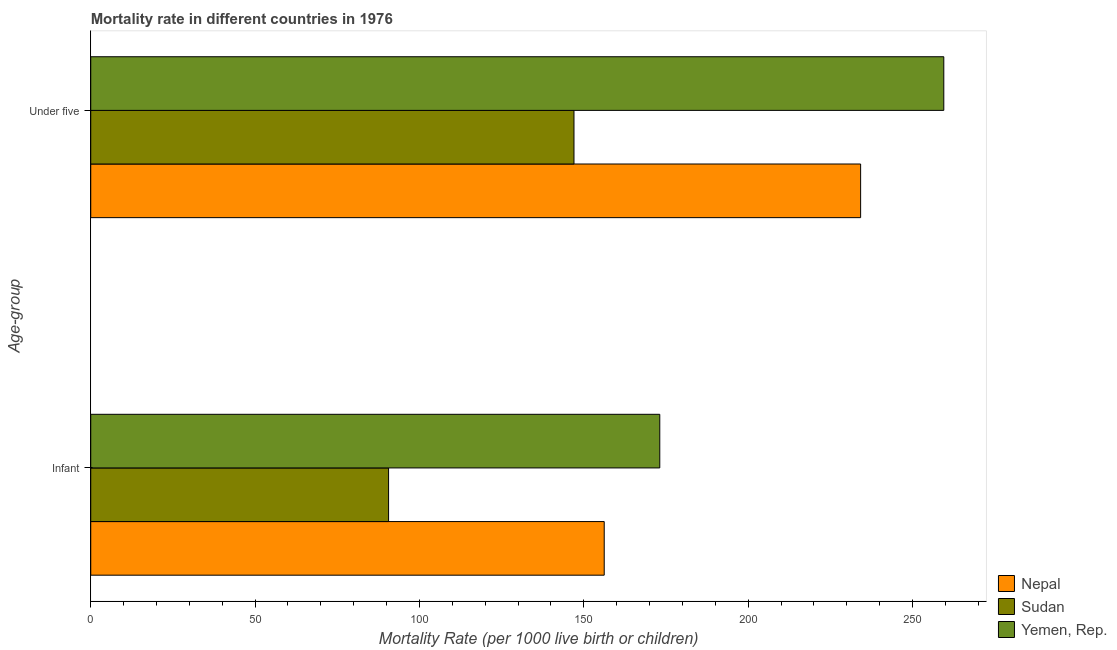How many different coloured bars are there?
Make the answer very short. 3. How many groups of bars are there?
Offer a terse response. 2. Are the number of bars on each tick of the Y-axis equal?
Your answer should be very brief. Yes. How many bars are there on the 1st tick from the bottom?
Your answer should be very brief. 3. What is the label of the 1st group of bars from the top?
Keep it short and to the point. Under five. What is the under-5 mortality rate in Nepal?
Ensure brevity in your answer.  234.2. Across all countries, what is the maximum under-5 mortality rate?
Offer a terse response. 259.5. Across all countries, what is the minimum under-5 mortality rate?
Give a very brief answer. 147. In which country was the under-5 mortality rate maximum?
Ensure brevity in your answer.  Yemen, Rep. In which country was the under-5 mortality rate minimum?
Provide a short and direct response. Sudan. What is the total infant mortality rate in the graph?
Offer a terse response. 419.9. What is the difference between the under-5 mortality rate in Yemen, Rep. and that in Nepal?
Provide a short and direct response. 25.3. What is the difference between the infant mortality rate in Sudan and the under-5 mortality rate in Yemen, Rep.?
Your response must be concise. -168.9. What is the average infant mortality rate per country?
Your response must be concise. 139.97. What is the difference between the under-5 mortality rate and infant mortality rate in Nepal?
Your answer should be very brief. 78. What is the ratio of the under-5 mortality rate in Yemen, Rep. to that in Nepal?
Ensure brevity in your answer.  1.11. Is the under-5 mortality rate in Sudan less than that in Nepal?
Offer a very short reply. Yes. In how many countries, is the infant mortality rate greater than the average infant mortality rate taken over all countries?
Ensure brevity in your answer.  2. What does the 3rd bar from the top in Infant represents?
Your response must be concise. Nepal. What does the 2nd bar from the bottom in Infant represents?
Provide a short and direct response. Sudan. How many bars are there?
Keep it short and to the point. 6. What is the difference between two consecutive major ticks on the X-axis?
Provide a succinct answer. 50. Does the graph contain any zero values?
Offer a terse response. No. Does the graph contain grids?
Your answer should be very brief. No. Where does the legend appear in the graph?
Ensure brevity in your answer.  Bottom right. How many legend labels are there?
Provide a succinct answer. 3. How are the legend labels stacked?
Make the answer very short. Vertical. What is the title of the graph?
Make the answer very short. Mortality rate in different countries in 1976. Does "Tuvalu" appear as one of the legend labels in the graph?
Offer a very short reply. No. What is the label or title of the X-axis?
Your answer should be very brief. Mortality Rate (per 1000 live birth or children). What is the label or title of the Y-axis?
Give a very brief answer. Age-group. What is the Mortality Rate (per 1000 live birth or children) of Nepal in Infant?
Keep it short and to the point. 156.2. What is the Mortality Rate (per 1000 live birth or children) of Sudan in Infant?
Ensure brevity in your answer.  90.6. What is the Mortality Rate (per 1000 live birth or children) in Yemen, Rep. in Infant?
Give a very brief answer. 173.1. What is the Mortality Rate (per 1000 live birth or children) of Nepal in Under five?
Make the answer very short. 234.2. What is the Mortality Rate (per 1000 live birth or children) in Sudan in Under five?
Provide a succinct answer. 147. What is the Mortality Rate (per 1000 live birth or children) in Yemen, Rep. in Under five?
Your answer should be very brief. 259.5. Across all Age-group, what is the maximum Mortality Rate (per 1000 live birth or children) of Nepal?
Make the answer very short. 234.2. Across all Age-group, what is the maximum Mortality Rate (per 1000 live birth or children) of Sudan?
Your answer should be very brief. 147. Across all Age-group, what is the maximum Mortality Rate (per 1000 live birth or children) of Yemen, Rep.?
Offer a terse response. 259.5. Across all Age-group, what is the minimum Mortality Rate (per 1000 live birth or children) of Nepal?
Give a very brief answer. 156.2. Across all Age-group, what is the minimum Mortality Rate (per 1000 live birth or children) of Sudan?
Your answer should be very brief. 90.6. Across all Age-group, what is the minimum Mortality Rate (per 1000 live birth or children) of Yemen, Rep.?
Make the answer very short. 173.1. What is the total Mortality Rate (per 1000 live birth or children) in Nepal in the graph?
Ensure brevity in your answer.  390.4. What is the total Mortality Rate (per 1000 live birth or children) in Sudan in the graph?
Your answer should be compact. 237.6. What is the total Mortality Rate (per 1000 live birth or children) in Yemen, Rep. in the graph?
Offer a very short reply. 432.6. What is the difference between the Mortality Rate (per 1000 live birth or children) of Nepal in Infant and that in Under five?
Give a very brief answer. -78. What is the difference between the Mortality Rate (per 1000 live birth or children) of Sudan in Infant and that in Under five?
Give a very brief answer. -56.4. What is the difference between the Mortality Rate (per 1000 live birth or children) of Yemen, Rep. in Infant and that in Under five?
Your answer should be compact. -86.4. What is the difference between the Mortality Rate (per 1000 live birth or children) in Nepal in Infant and the Mortality Rate (per 1000 live birth or children) in Sudan in Under five?
Your response must be concise. 9.2. What is the difference between the Mortality Rate (per 1000 live birth or children) in Nepal in Infant and the Mortality Rate (per 1000 live birth or children) in Yemen, Rep. in Under five?
Ensure brevity in your answer.  -103.3. What is the difference between the Mortality Rate (per 1000 live birth or children) in Sudan in Infant and the Mortality Rate (per 1000 live birth or children) in Yemen, Rep. in Under five?
Your answer should be very brief. -168.9. What is the average Mortality Rate (per 1000 live birth or children) of Nepal per Age-group?
Your response must be concise. 195.2. What is the average Mortality Rate (per 1000 live birth or children) of Sudan per Age-group?
Your answer should be very brief. 118.8. What is the average Mortality Rate (per 1000 live birth or children) of Yemen, Rep. per Age-group?
Your answer should be very brief. 216.3. What is the difference between the Mortality Rate (per 1000 live birth or children) in Nepal and Mortality Rate (per 1000 live birth or children) in Sudan in Infant?
Make the answer very short. 65.6. What is the difference between the Mortality Rate (per 1000 live birth or children) in Nepal and Mortality Rate (per 1000 live birth or children) in Yemen, Rep. in Infant?
Keep it short and to the point. -16.9. What is the difference between the Mortality Rate (per 1000 live birth or children) in Sudan and Mortality Rate (per 1000 live birth or children) in Yemen, Rep. in Infant?
Your answer should be very brief. -82.5. What is the difference between the Mortality Rate (per 1000 live birth or children) in Nepal and Mortality Rate (per 1000 live birth or children) in Sudan in Under five?
Ensure brevity in your answer.  87.2. What is the difference between the Mortality Rate (per 1000 live birth or children) in Nepal and Mortality Rate (per 1000 live birth or children) in Yemen, Rep. in Under five?
Your answer should be very brief. -25.3. What is the difference between the Mortality Rate (per 1000 live birth or children) of Sudan and Mortality Rate (per 1000 live birth or children) of Yemen, Rep. in Under five?
Offer a very short reply. -112.5. What is the ratio of the Mortality Rate (per 1000 live birth or children) of Nepal in Infant to that in Under five?
Your answer should be compact. 0.67. What is the ratio of the Mortality Rate (per 1000 live birth or children) of Sudan in Infant to that in Under five?
Ensure brevity in your answer.  0.62. What is the ratio of the Mortality Rate (per 1000 live birth or children) of Yemen, Rep. in Infant to that in Under five?
Your response must be concise. 0.67. What is the difference between the highest and the second highest Mortality Rate (per 1000 live birth or children) of Nepal?
Provide a short and direct response. 78. What is the difference between the highest and the second highest Mortality Rate (per 1000 live birth or children) in Sudan?
Provide a short and direct response. 56.4. What is the difference between the highest and the second highest Mortality Rate (per 1000 live birth or children) in Yemen, Rep.?
Offer a very short reply. 86.4. What is the difference between the highest and the lowest Mortality Rate (per 1000 live birth or children) of Sudan?
Your answer should be very brief. 56.4. What is the difference between the highest and the lowest Mortality Rate (per 1000 live birth or children) in Yemen, Rep.?
Ensure brevity in your answer.  86.4. 